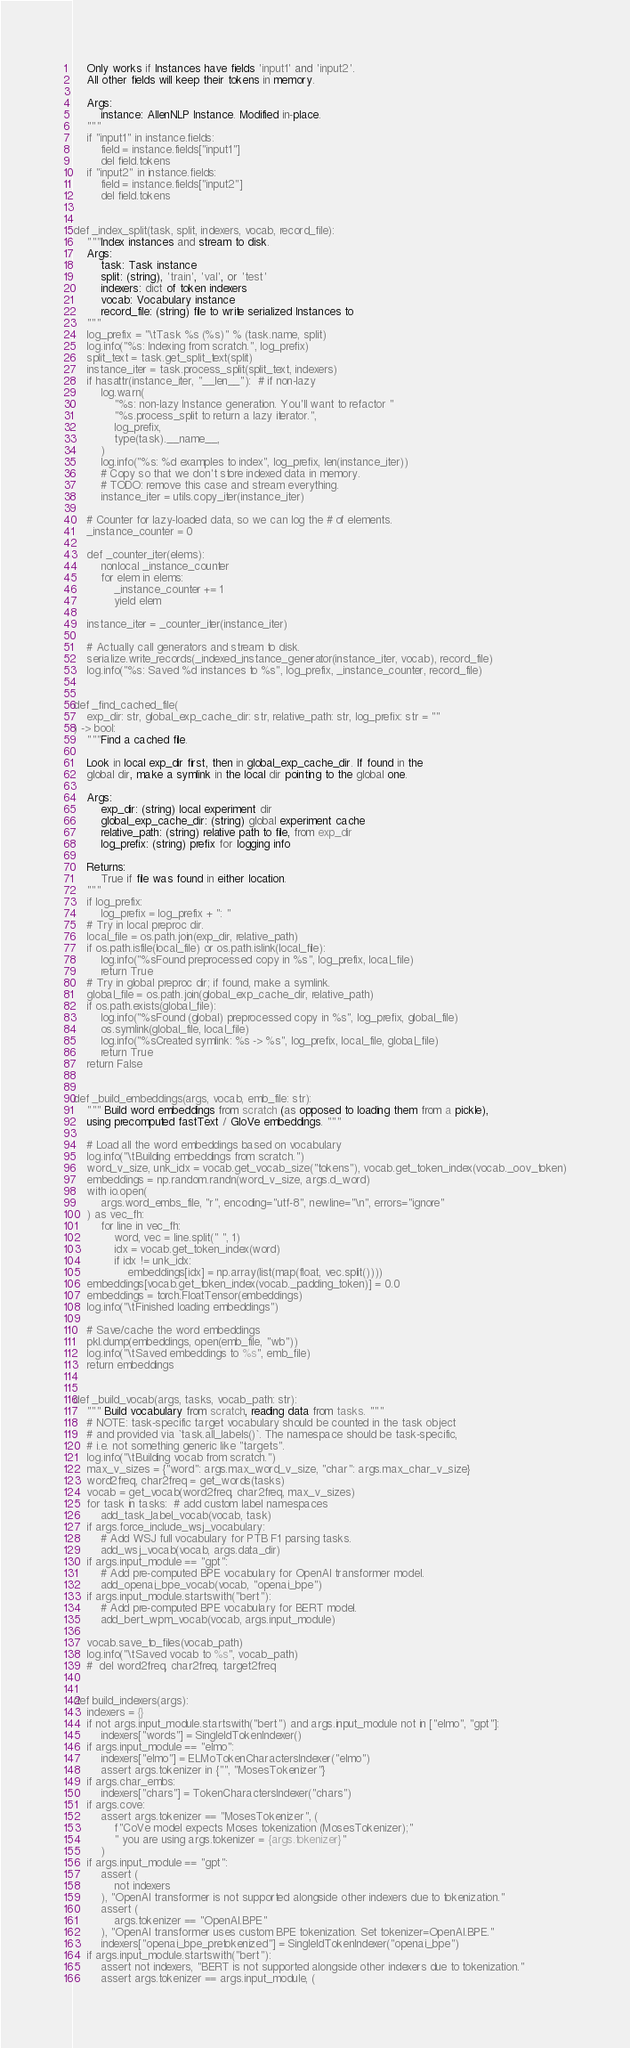Convert code to text. <code><loc_0><loc_0><loc_500><loc_500><_Python_>    Only works if Instances have fields 'input1' and 'input2'.
    All other fields will keep their tokens in memory.

    Args:
        instance: AllenNLP Instance. Modified in-place.
    """
    if "input1" in instance.fields:
        field = instance.fields["input1"]
        del field.tokens
    if "input2" in instance.fields:
        field = instance.fields["input2"]
        del field.tokens


def _index_split(task, split, indexers, vocab, record_file):
    """Index instances and stream to disk.
    Args:
        task: Task instance
        split: (string), 'train', 'val', or 'test'
        indexers: dict of token indexers
        vocab: Vocabulary instance
        record_file: (string) file to write serialized Instances to
    """
    log_prefix = "\tTask %s (%s)" % (task.name, split)
    log.info("%s: Indexing from scratch.", log_prefix)
    split_text = task.get_split_text(split)
    instance_iter = task.process_split(split_text, indexers)
    if hasattr(instance_iter, "__len__"):  # if non-lazy
        log.warn(
            "%s: non-lazy Instance generation. You'll want to refactor "
            "%s.process_split to return a lazy iterator.",
            log_prefix,
            type(task).__name__,
        )
        log.info("%s: %d examples to index", log_prefix, len(instance_iter))
        # Copy so that we don't store indexed data in memory.
        # TODO: remove this case and stream everything.
        instance_iter = utils.copy_iter(instance_iter)

    # Counter for lazy-loaded data, so we can log the # of elements.
    _instance_counter = 0

    def _counter_iter(elems):
        nonlocal _instance_counter
        for elem in elems:
            _instance_counter += 1
            yield elem

    instance_iter = _counter_iter(instance_iter)

    # Actually call generators and stream to disk.
    serialize.write_records(_indexed_instance_generator(instance_iter, vocab), record_file)
    log.info("%s: Saved %d instances to %s", log_prefix, _instance_counter, record_file)


def _find_cached_file(
    exp_dir: str, global_exp_cache_dir: str, relative_path: str, log_prefix: str = ""
) -> bool:
    """Find a cached file.

    Look in local exp_dir first, then in global_exp_cache_dir. If found in the
    global dir, make a symlink in the local dir pointing to the global one.

    Args:
        exp_dir: (string) local experiment dir
        global_exp_cache_dir: (string) global experiment cache
        relative_path: (string) relative path to file, from exp_dir
        log_prefix: (string) prefix for logging info

    Returns:
        True if file was found in either location.
    """
    if log_prefix:
        log_prefix = log_prefix + ": "
    # Try in local preproc dir.
    local_file = os.path.join(exp_dir, relative_path)
    if os.path.isfile(local_file) or os.path.islink(local_file):
        log.info("%sFound preprocessed copy in %s", log_prefix, local_file)
        return True
    # Try in global preproc dir; if found, make a symlink.
    global_file = os.path.join(global_exp_cache_dir, relative_path)
    if os.path.exists(global_file):
        log.info("%sFound (global) preprocessed copy in %s", log_prefix, global_file)
        os.symlink(global_file, local_file)
        log.info("%sCreated symlink: %s -> %s", log_prefix, local_file, global_file)
        return True
    return False


def _build_embeddings(args, vocab, emb_file: str):
    """ Build word embeddings from scratch (as opposed to loading them from a pickle),
    using precomputed fastText / GloVe embeddings. """

    # Load all the word embeddings based on vocabulary
    log.info("\tBuilding embeddings from scratch.")
    word_v_size, unk_idx = vocab.get_vocab_size("tokens"), vocab.get_token_index(vocab._oov_token)
    embeddings = np.random.randn(word_v_size, args.d_word)
    with io.open(
        args.word_embs_file, "r", encoding="utf-8", newline="\n", errors="ignore"
    ) as vec_fh:
        for line in vec_fh:
            word, vec = line.split(" ", 1)
            idx = vocab.get_token_index(word)
            if idx != unk_idx:
                embeddings[idx] = np.array(list(map(float, vec.split())))
    embeddings[vocab.get_token_index(vocab._padding_token)] = 0.0
    embeddings = torch.FloatTensor(embeddings)
    log.info("\tFinished loading embeddings")

    # Save/cache the word embeddings
    pkl.dump(embeddings, open(emb_file, "wb"))
    log.info("\tSaved embeddings to %s", emb_file)
    return embeddings


def _build_vocab(args, tasks, vocab_path: str):
    """ Build vocabulary from scratch, reading data from tasks. """
    # NOTE: task-specific target vocabulary should be counted in the task object
    # and provided via `task.all_labels()`. The namespace should be task-specific,
    # i.e. not something generic like "targets".
    log.info("\tBuilding vocab from scratch.")
    max_v_sizes = {"word": args.max_word_v_size, "char": args.max_char_v_size}
    word2freq, char2freq = get_words(tasks)
    vocab = get_vocab(word2freq, char2freq, max_v_sizes)
    for task in tasks:  # add custom label namespaces
        add_task_label_vocab(vocab, task)
    if args.force_include_wsj_vocabulary:
        # Add WSJ full vocabulary for PTB F1 parsing tasks.
        add_wsj_vocab(vocab, args.data_dir)
    if args.input_module == "gpt":
        # Add pre-computed BPE vocabulary for OpenAI transformer model.
        add_openai_bpe_vocab(vocab, "openai_bpe")
    if args.input_module.startswith("bert"):
        # Add pre-computed BPE vocabulary for BERT model.
        add_bert_wpm_vocab(vocab, args.input_module)

    vocab.save_to_files(vocab_path)
    log.info("\tSaved vocab to %s", vocab_path)
    #  del word2freq, char2freq, target2freq


def build_indexers(args):
    indexers = {}
    if not args.input_module.startswith("bert") and args.input_module not in ["elmo", "gpt"]:
        indexers["words"] = SingleIdTokenIndexer()
    if args.input_module == "elmo":
        indexers["elmo"] = ELMoTokenCharactersIndexer("elmo")
        assert args.tokenizer in {"", "MosesTokenizer"}
    if args.char_embs:
        indexers["chars"] = TokenCharactersIndexer("chars")
    if args.cove:
        assert args.tokenizer == "MosesTokenizer", (
            f"CoVe model expects Moses tokenization (MosesTokenizer);"
            " you are using args.tokenizer = {args.tokenizer}"
        )
    if args.input_module == "gpt":
        assert (
            not indexers
        ), "OpenAI transformer is not supported alongside other indexers due to tokenization."
        assert (
            args.tokenizer == "OpenAI.BPE"
        ), "OpenAI transformer uses custom BPE tokenization. Set tokenizer=OpenAI.BPE."
        indexers["openai_bpe_pretokenized"] = SingleIdTokenIndexer("openai_bpe")
    if args.input_module.startswith("bert"):
        assert not indexers, "BERT is not supported alongside other indexers due to tokenization."
        assert args.tokenizer == args.input_module, (</code> 